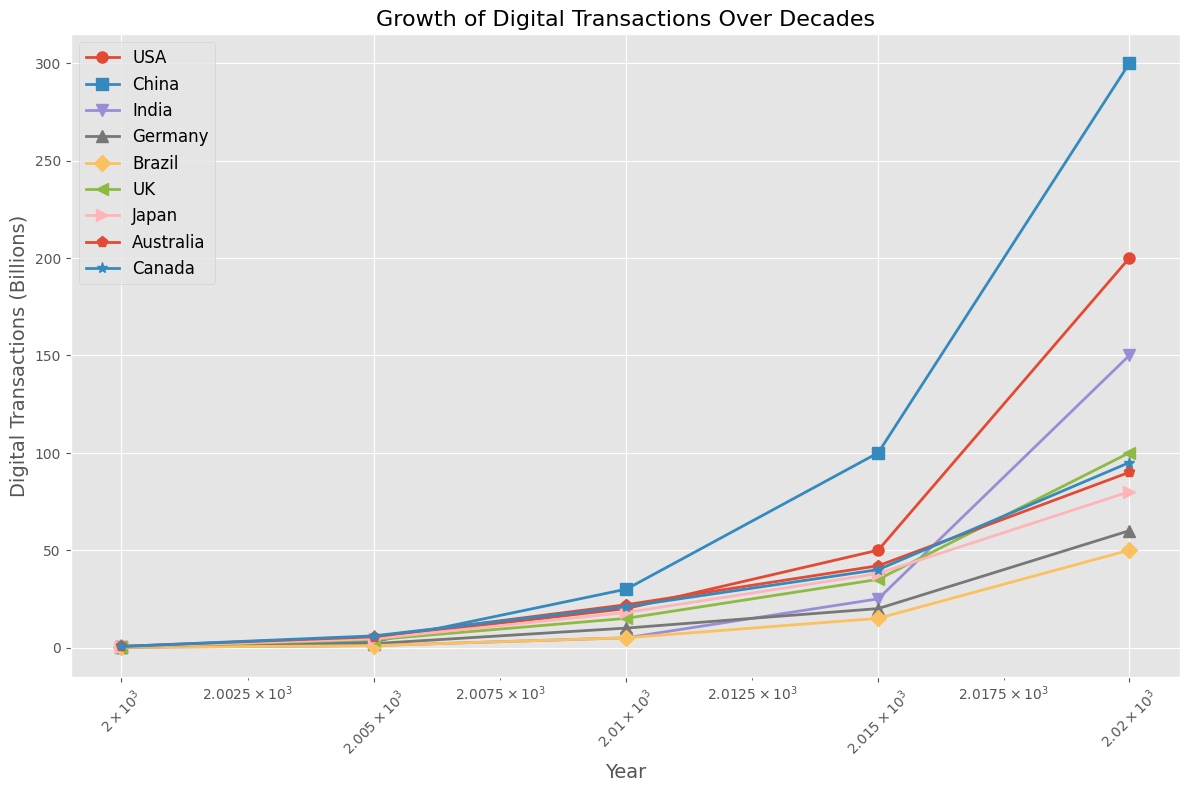Which country has the highest number of digital transactions in 2020? We look at the rightmost end of the plot for 2020 and identify which country’s plot marker is highest on the y-axis.
Answer: China What is the increase in digital transactions for India from 2000 to 2020? Locate India's data points at 2000 and 2020 and subtract the former from the latter: 150 - 0.05
Answer: 149.95 Comparing 2010, which countries have more than 15 billion digital transactions? Identify the data points for 2010 and check their values: USA (20 billion), China (30 billion), and Japan (18 billion) are above 15 billion.
Answer: USA, China, Japan Which country shows the greatest relative growth between 2000 and 2020? Calculate the ratio of 2020 to 2000 for each country and compare them. China grows from 0.2 to 300 (1500 times), India from 0.05 to 150 (3000 times), making India's relative growth the highest.
Answer: India Between 2015 and 2020, which country had the slowest growth in digital transactions? Calculate the growth by subtracting the 2015 value from the 2020 value for each country and identify the smallest increase. Germany’s growth from 20 to 60 (40 billion) is the smallest.
Answer: Germany Comparing the trends, which country showed a consistent growth without any significant drops throughout the years? Examine the trajectory of each country’s line on the logscale plot for any downward segments; China and the USA both show consistent upward trends.
Answer: China, USA How does Germany's 2020 digital transactions compare to Brazil's in the same year? Identify Germany and Brazil's markers for 2020 and compare their values; Germany (60 billion), Brazil (50 billion).
Answer: Germany has more What is the average number of digital transactions in 2020 for the USA, China, and India? Sum the 2020 values for USA (200), China (300), India (150) and divide by 3: (200 + 300 + 150) / 3 = 650 / 3 = 216.67
Answer: 216.67 If you add the total digital transactions for all countries in 2010, what is the sum? Sum the values of all the countries for 2010: 20 + 30 + 5 + 10 + 5 + 15 + 18 + 22 + 21 = 146 billion
Answer: 146 billion When comparing the UK and Japan, which country had higher digital transactions in 2015? Look at the data points for 2015 for the UK (35 billion) and Japan (38 billion); Japan's value is higher.
Answer: Japan 